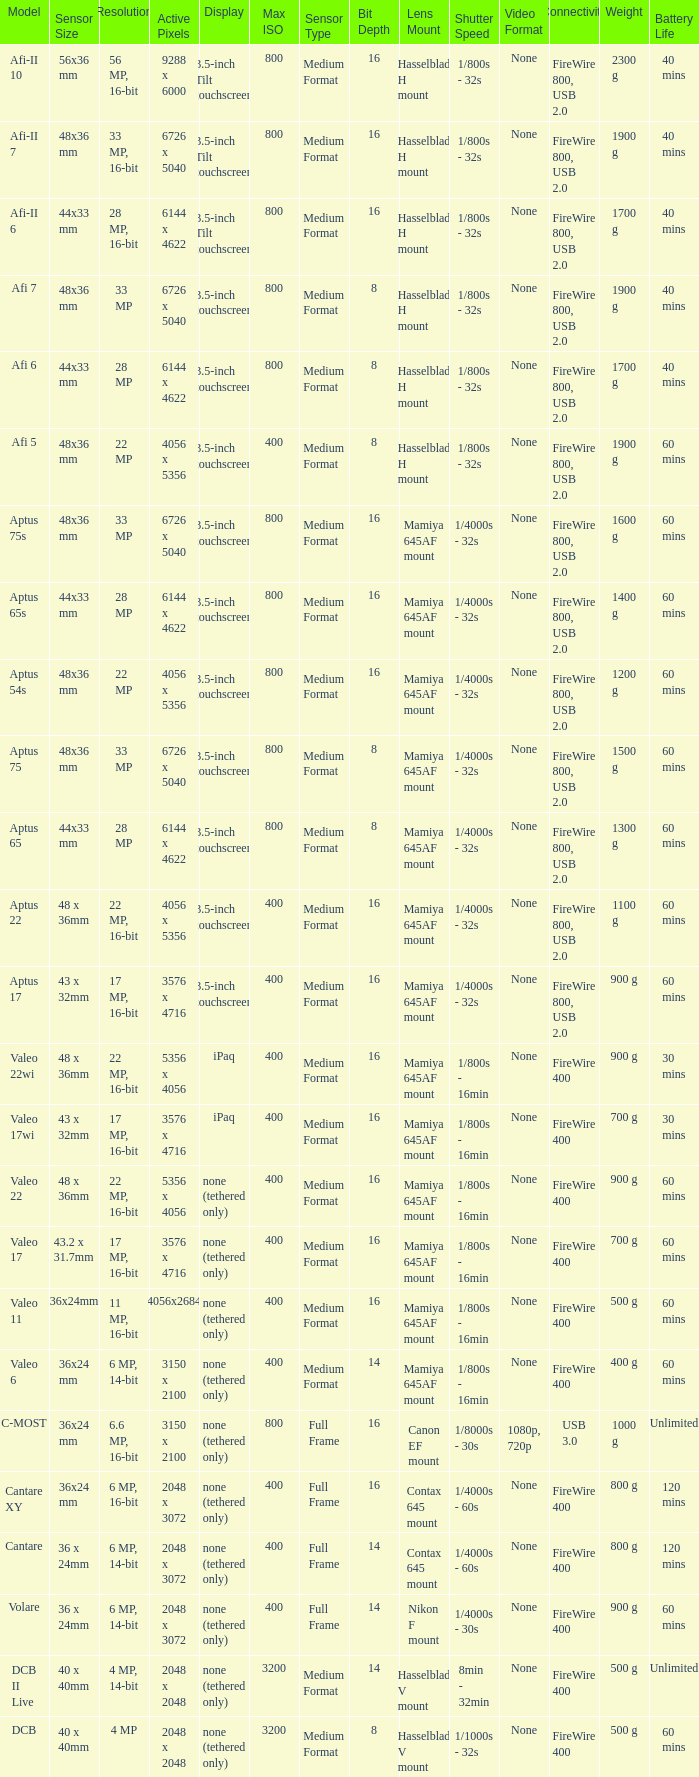Could you parse the entire table as a dict? {'header': ['Model', 'Sensor Size', 'Resolution', 'Active Pixels', 'Display', 'Max ISO', 'Sensor Type', 'Bit Depth', 'Lens Mount', 'Shutter Speed', 'Video Format', 'Connectivity', 'Weight', 'Battery Life'], 'rows': [['Afi-II 10', '56x36 mm', '56 MP, 16-bit', '9288 x 6000', '3.5-inch Tilt touchscreen', '800', 'Medium Format', '16', 'Hasselblad H mount', '1/800s - 32s', 'None', 'FireWire 800, USB 2.0', '2300 g', '40 mins'], ['Afi-II 7', '48x36 mm', '33 MP, 16-bit', '6726 x 5040', '3.5-inch Tilt touchscreen', '800', 'Medium Format', '16', 'Hasselblad H mount', '1/800s - 32s', 'None', 'FireWire 800, USB 2.0', '1900 g', '40 mins'], ['Afi-II 6', '44x33 mm', '28 MP, 16-bit', '6144 x 4622', '3.5-inch Tilt touchscreen', '800', 'Medium Format', '16', 'Hasselblad H mount', '1/800s - 32s', 'None', 'FireWire 800, USB 2.0', '1700 g', '40 mins'], ['Afi 7', '48x36 mm', '33 MP', '6726 x 5040', '3.5-inch touchscreen', '800', 'Medium Format', '8', 'Hasselblad H mount', '1/800s - 32s', 'None', 'FireWire 800, USB 2.0', '1900 g', '40 mins'], ['Afi 6', '44x33 mm', '28 MP', '6144 x 4622', '3.5-inch touchscreen', '800', 'Medium Format', '8', 'Hasselblad H mount', '1/800s - 32s', 'None', 'FireWire 800, USB 2.0', '1700 g', '40 mins'], ['Afi 5', '48x36 mm', '22 MP', '4056 x 5356', '3.5-inch touchscreen', '400', 'Medium Format', '8', 'Hasselblad H mount', '1/800s - 32s', 'None', 'FireWire 800, USB 2.0', '1900 g', '60 mins'], ['Aptus 75s', '48x36 mm', '33 MP', '6726 x 5040', '3.5-inch touchscreen', '800', 'Medium Format', '16', 'Mamiya 645AF mount', '1/4000s - 32s', 'None', 'FireWire 800, USB 2.0', '1600 g', '60 mins'], ['Aptus 65s', '44x33 mm', '28 MP', '6144 x 4622', '3.5-inch touchscreen', '800', 'Medium Format', '16', 'Mamiya 645AF mount', '1/4000s - 32s', 'None', 'FireWire 800, USB 2.0', '1400 g', '60 mins'], ['Aptus 54s', '48x36 mm', '22 MP', '4056 x 5356', '3.5-inch touchscreen', '800', 'Medium Format', '16', 'Mamiya 645AF mount', '1/4000s - 32s', 'None', 'FireWire 800, USB 2.0', '1200 g', '60 mins'], ['Aptus 75', '48x36 mm', '33 MP', '6726 x 5040', '3.5-inch touchscreen', '800', 'Medium Format', '8', 'Mamiya 645AF mount', '1/4000s - 32s', 'None', 'FireWire 800, USB 2.0', '1500 g', '60 mins'], ['Aptus 65', '44x33 mm', '28 MP', '6144 x 4622', '3.5-inch touchscreen', '800', 'Medium Format', '8', 'Mamiya 645AF mount', '1/4000s - 32s', 'None', 'FireWire 800, USB 2.0', '1300 g', '60 mins'], ['Aptus 22', '48 x 36mm', '22 MP, 16-bit', '4056 x 5356', '3.5-inch touchscreen', '400', 'Medium Format', '16', 'Mamiya 645AF mount', '1/4000s - 32s', 'None', 'FireWire 800, USB 2.0', '1100 g', '60 mins'], ['Aptus 17', '43 x 32mm', '17 MP, 16-bit', '3576 x 4716', '3.5-inch touchscreen', '400', 'Medium Format', '16', 'Mamiya 645AF mount', '1/4000s - 32s', 'None', 'FireWire 800, USB 2.0', '900 g', '60 mins'], ['Valeo 22wi', '48 x 36mm', '22 MP, 16-bit', '5356 x 4056', 'iPaq', '400', 'Medium Format', '16', 'Mamiya 645AF mount', '1/800s - 16min', 'None', 'FireWire 400', '900 g', '30 mins'], ['Valeo 17wi', '43 x 32mm', '17 MP, 16-bit', '3576 x 4716', 'iPaq', '400', 'Medium Format', '16', 'Mamiya 645AF mount', '1/800s - 16min', 'None', 'FireWire 400', '700 g', '30 mins'], ['Valeo 22', '48 x 36mm', '22 MP, 16-bit', '5356 x 4056', 'none (tethered only)', '400', 'Medium Format', '16', 'Mamiya 645AF mount', '1/800s - 16min', 'None', 'FireWire 400', '900 g', '60 mins'], ['Valeo 17', '43.2 x 31.7mm', '17 MP, 16-bit', '3576 x 4716', 'none (tethered only)', '400', 'Medium Format', '16', 'Mamiya 645AF mount', '1/800s - 16min', 'None', 'FireWire 400', '700 g', '60 mins'], ['Valeo 11', '36x24mm', '11 MP, 16-bit', '4056x2684', 'none (tethered only)', '400', 'Medium Format', '16', 'Mamiya 645AF mount', '1/800s - 16min', 'None', 'FireWire 400', '500 g', '60 mins'], ['Valeo 6', '36x24 mm', '6 MP, 14-bit', '3150 x 2100', 'none (tethered only)', '400', 'Medium Format', '14', 'Mamiya 645AF mount', '1/800s - 16min', 'None', 'FireWire 400', '400 g', '60 mins'], ['C-MOST', '36x24 mm', '6.6 MP, 16-bit', '3150 x 2100', 'none (tethered only)', '800', 'Full Frame', '16', 'Canon EF mount', '1/8000s - 30s', '1080p, 720p', 'USB 3.0', '1000 g', 'Unlimited'], ['Cantare XY', '36x24 mm', '6 MP, 16-bit', '2048 x 3072', 'none (tethered only)', '400', 'Full Frame', '16', 'Contax 645 mount', '1/4000s - 60s', 'None', 'FireWire 400', '800 g', '120 mins'], ['Cantare', '36 x 24mm', '6 MP, 14-bit', '2048 x 3072', 'none (tethered only)', '400', 'Full Frame', '14', 'Contax 645 mount', '1/4000s - 60s', 'None', 'FireWire 400', '800 g', '120 mins'], ['Volare', '36 x 24mm', '6 MP, 14-bit', '2048 x 3072', 'none (tethered only)', '400', 'Full Frame', '14', 'Nikon F mount', '1/4000s - 30s', 'None', 'FireWire 400', '900 g', '60 mins'], ['DCB II Live', '40 x 40mm', '4 MP, 14-bit', '2048 x 2048', 'none (tethered only)', '3200', 'Medium Format', '14', 'Hasselblad V mount', '8min - 32min', 'None', 'FireWire 400', '500 g', 'Unlimited'], ['DCB', '40 x 40mm', '4 MP', '2048 x 2048', 'none (tethered only)', '3200', 'Medium Format', '8', 'Hasselblad V mount', '1/1000s - 32s', 'None', 'FireWire 400', '500 g', '60 mins']]} What are the active pixels of the cantare model? 2048 x 3072. 